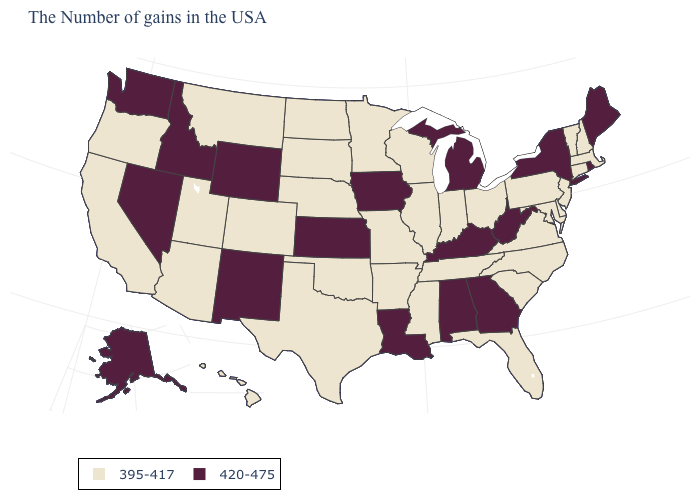What is the highest value in the South ?
Concise answer only. 420-475. Is the legend a continuous bar?
Be succinct. No. What is the value of Ohio?
Be succinct. 395-417. Does the map have missing data?
Answer briefly. No. What is the highest value in states that border Washington?
Give a very brief answer. 420-475. Does Maine have a higher value than Rhode Island?
Keep it brief. No. What is the value of Ohio?
Give a very brief answer. 395-417. Does Maine have the highest value in the USA?
Write a very short answer. Yes. Does the map have missing data?
Give a very brief answer. No. Among the states that border Maryland , does West Virginia have the highest value?
Answer briefly. Yes. What is the lowest value in states that border Pennsylvania?
Write a very short answer. 395-417. How many symbols are there in the legend?
Quick response, please. 2. Name the states that have a value in the range 420-475?
Short answer required. Maine, Rhode Island, New York, West Virginia, Georgia, Michigan, Kentucky, Alabama, Louisiana, Iowa, Kansas, Wyoming, New Mexico, Idaho, Nevada, Washington, Alaska. Name the states that have a value in the range 420-475?
Give a very brief answer. Maine, Rhode Island, New York, West Virginia, Georgia, Michigan, Kentucky, Alabama, Louisiana, Iowa, Kansas, Wyoming, New Mexico, Idaho, Nevada, Washington, Alaska. Name the states that have a value in the range 420-475?
Short answer required. Maine, Rhode Island, New York, West Virginia, Georgia, Michigan, Kentucky, Alabama, Louisiana, Iowa, Kansas, Wyoming, New Mexico, Idaho, Nevada, Washington, Alaska. 